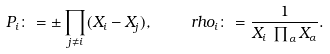<formula> <loc_0><loc_0><loc_500><loc_500>P _ { i } \colon = \pm \prod _ { j \ne i } ( X _ { i } - X _ { j } ) , \ \ \ \ r h o _ { i } \colon = \frac { 1 } { X _ { i } \, \prod _ { \alpha } X _ { \alpha } } .</formula> 